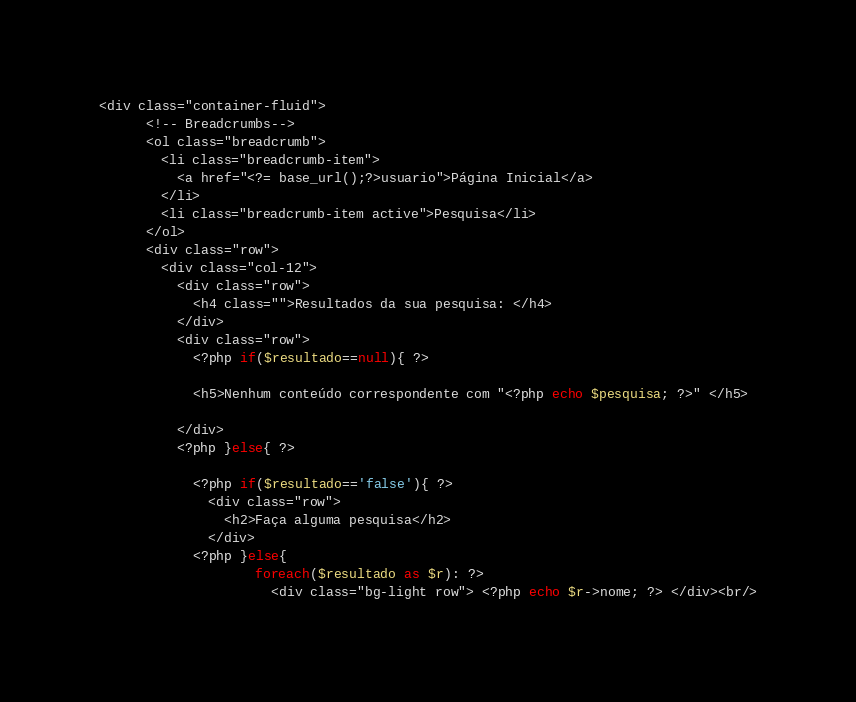<code> <loc_0><loc_0><loc_500><loc_500><_PHP_><div class="container-fluid">
      <!-- Breadcrumbs-->
      <ol class="breadcrumb">
        <li class="breadcrumb-item">
          <a href="<?= base_url();?>usuario">Página Inicial</a>
        </li>
        <li class="breadcrumb-item active">Pesquisa</li>
      </ol>
      <div class="row">
        <div class="col-12">
          <div class="row">
            <h4 class="">Resultados da sua pesquisa: </h4>
          </div>
          <div class="row">
            <?php if($resultado==null){ ?>

            <h5>Nenhum conteúdo correspondente com "<?php echo $pesquisa; ?>" </h5>
          
          </div>
          <?php }else{ ?>

            <?php if($resultado=='false'){ ?>
              <div class="row">
                <h2>Faça alguma pesquisa</h2>
              </div>  
            <?php }else{ 
                    foreach($resultado as $r): ?>
                      <div class="bg-light row"> <?php echo $r->nome; ?> </div><br/></code> 